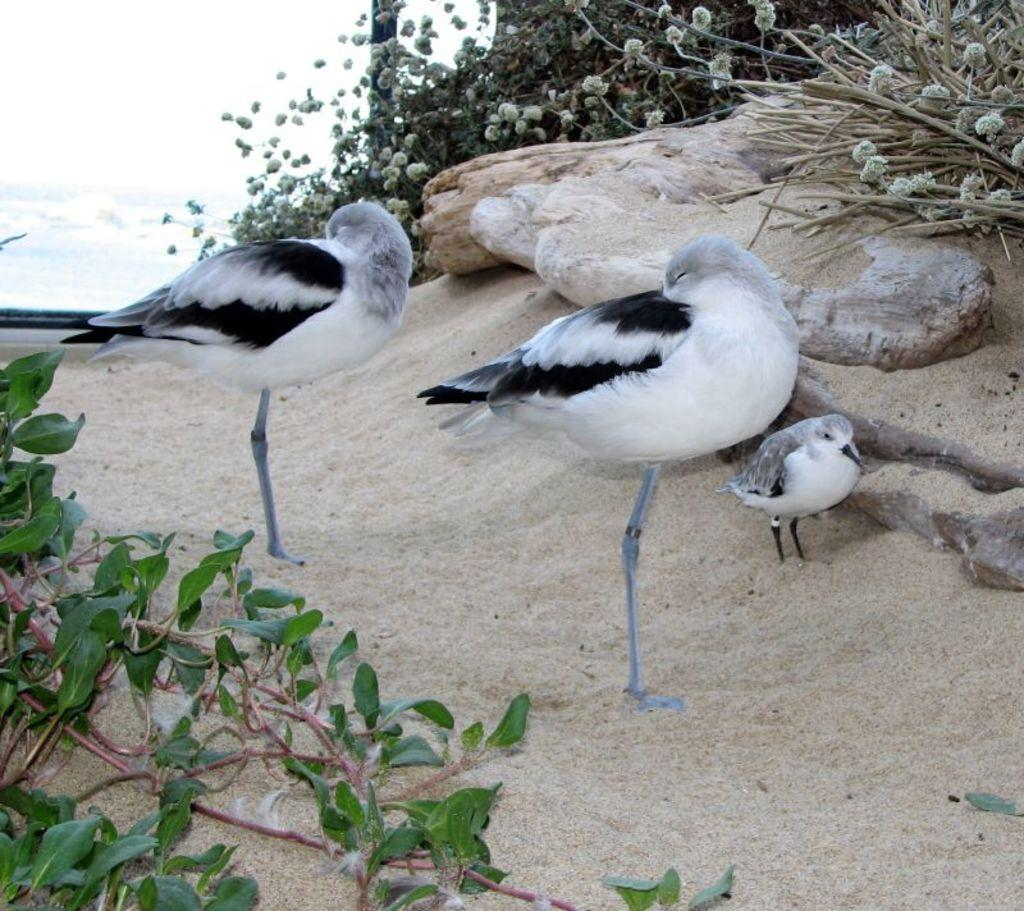What type of animals can be seen in the image? There are birds in the image. Where are the birds located? The birds are standing on the sand. What can be seen in the background of the image? There are twigs, rocks, and creepers present in the background of the image. What type of chain can be seen hanging from the birds in the image? There is no chain present in the image; the birds are standing on the sand without any visible attachments. 